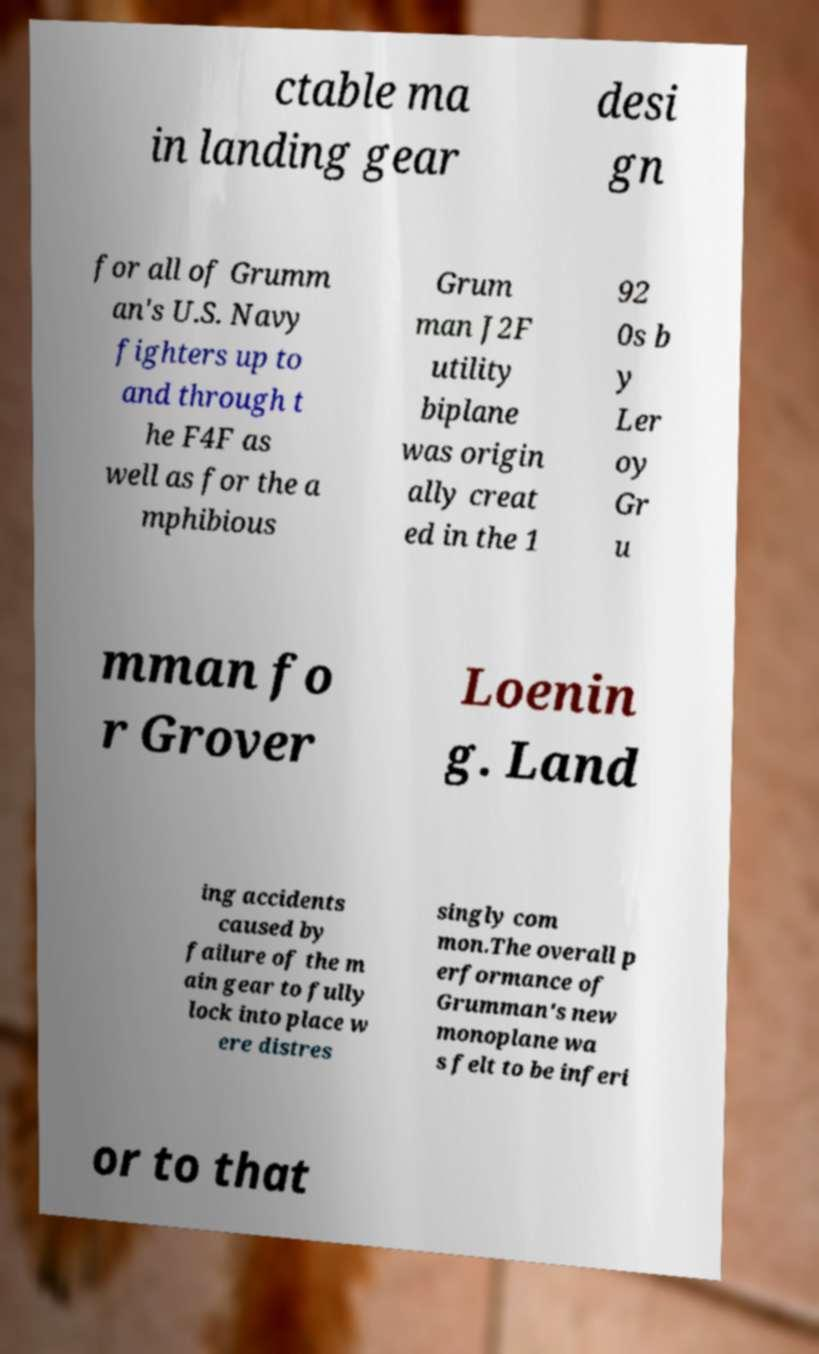For documentation purposes, I need the text within this image transcribed. Could you provide that? ctable ma in landing gear desi gn for all of Grumm an's U.S. Navy fighters up to and through t he F4F as well as for the a mphibious Grum man J2F utility biplane was origin ally creat ed in the 1 92 0s b y Ler oy Gr u mman fo r Grover Loenin g. Land ing accidents caused by failure of the m ain gear to fully lock into place w ere distres singly com mon.The overall p erformance of Grumman's new monoplane wa s felt to be inferi or to that 